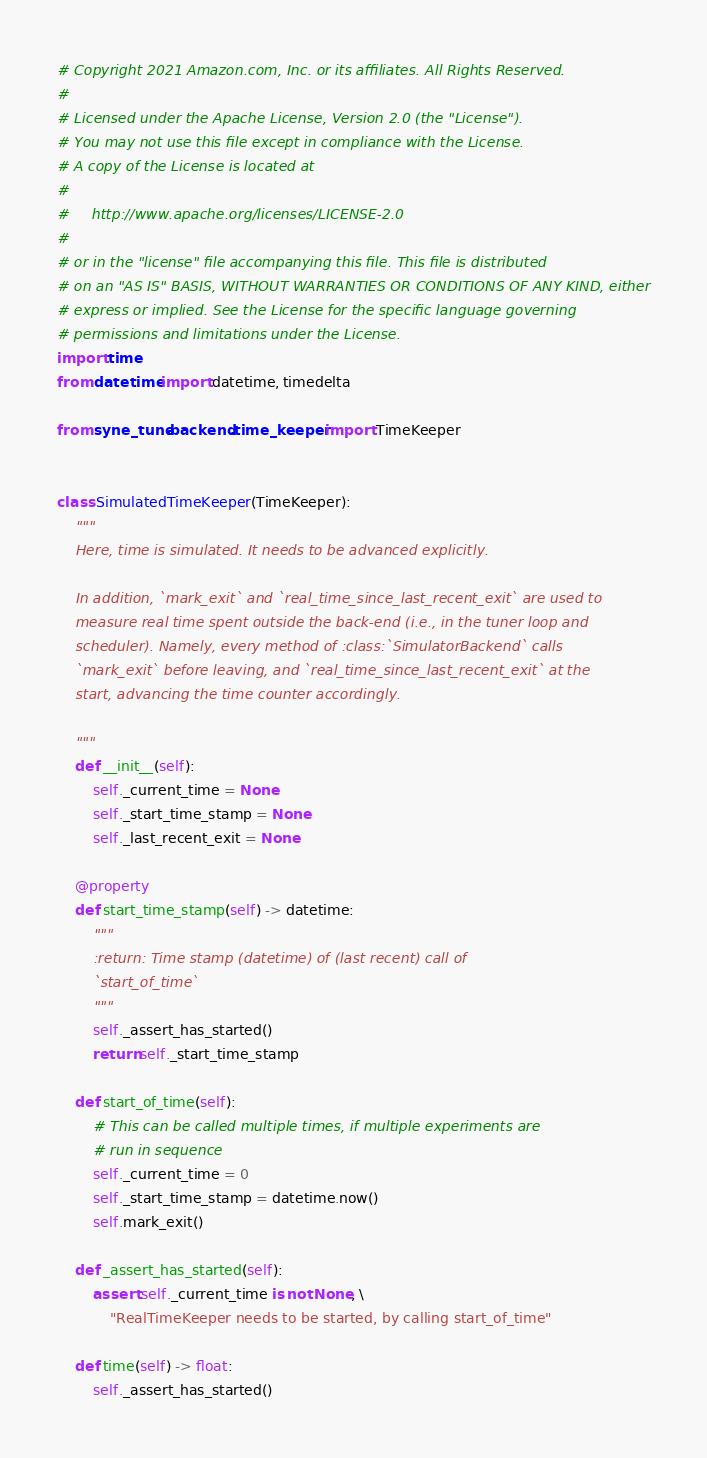Convert code to text. <code><loc_0><loc_0><loc_500><loc_500><_Python_># Copyright 2021 Amazon.com, Inc. or its affiliates. All Rights Reserved.
#
# Licensed under the Apache License, Version 2.0 (the "License").
# You may not use this file except in compliance with the License.
# A copy of the License is located at
#
#     http://www.apache.org/licenses/LICENSE-2.0
#
# or in the "license" file accompanying this file. This file is distributed
# on an "AS IS" BASIS, WITHOUT WARRANTIES OR CONDITIONS OF ANY KIND, either
# express or implied. See the License for the specific language governing
# permissions and limitations under the License.
import time
from datetime import datetime, timedelta

from syne_tune.backend.time_keeper import TimeKeeper


class SimulatedTimeKeeper(TimeKeeper):
    """
    Here, time is simulated. It needs to be advanced explicitly.

    In addition, `mark_exit` and `real_time_since_last_recent_exit` are used to
    measure real time spent outside the back-end (i.e., in the tuner loop and
    scheduler). Namely, every method of :class:`SimulatorBackend` calls
    `mark_exit` before leaving, and `real_time_since_last_recent_exit` at the
    start, advancing the time counter accordingly.

    """
    def __init__(self):
        self._current_time = None
        self._start_time_stamp = None
        self._last_recent_exit = None

    @property
    def start_time_stamp(self) -> datetime:
        """
        :return: Time stamp (datetime) of (last recent) call of
        `start_of_time`
        """
        self._assert_has_started()
        return self._start_time_stamp

    def start_of_time(self):
        # This can be called multiple times, if multiple experiments are
        # run in sequence
        self._current_time = 0
        self._start_time_stamp = datetime.now()
        self.mark_exit()

    def _assert_has_started(self):
        assert self._current_time is not None, \
            "RealTimeKeeper needs to be started, by calling start_of_time"

    def time(self) -> float:
        self._assert_has_started()</code> 